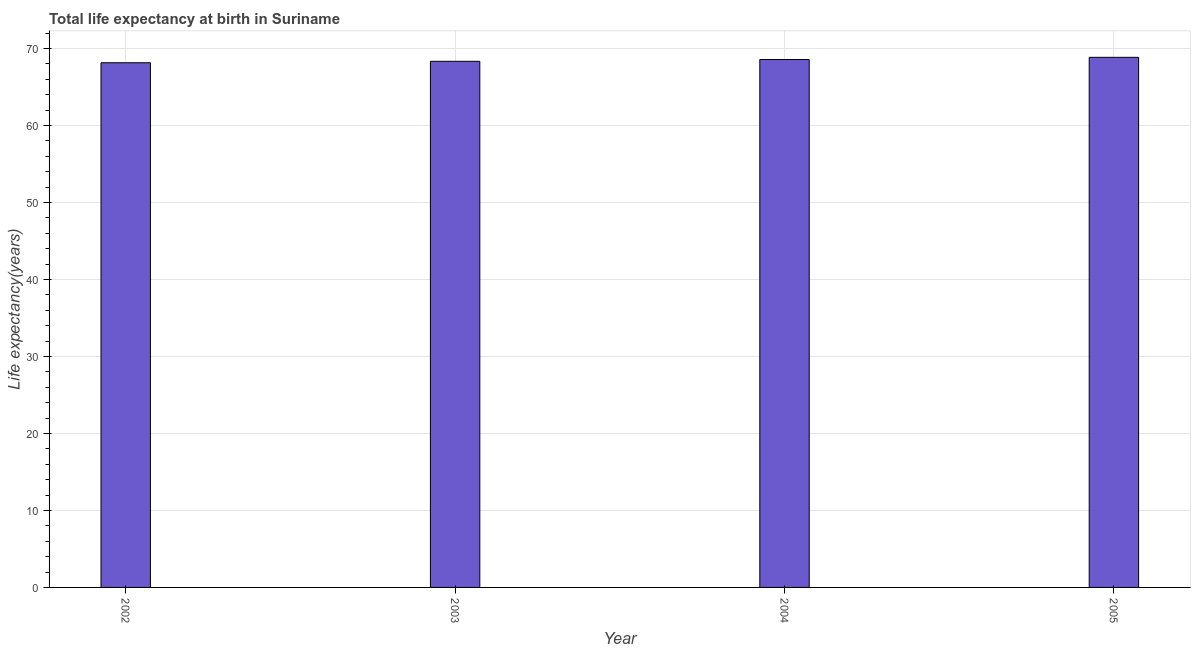Does the graph contain any zero values?
Your answer should be very brief. No. Does the graph contain grids?
Make the answer very short. Yes. What is the title of the graph?
Keep it short and to the point. Total life expectancy at birth in Suriname. What is the label or title of the Y-axis?
Offer a very short reply. Life expectancy(years). What is the life expectancy at birth in 2005?
Make the answer very short. 68.85. Across all years, what is the maximum life expectancy at birth?
Give a very brief answer. 68.85. Across all years, what is the minimum life expectancy at birth?
Your answer should be compact. 68.14. What is the sum of the life expectancy at birth?
Your response must be concise. 273.89. What is the difference between the life expectancy at birth in 2002 and 2004?
Provide a short and direct response. -0.42. What is the average life expectancy at birth per year?
Your answer should be compact. 68.47. What is the median life expectancy at birth?
Provide a succinct answer. 68.45. In how many years, is the life expectancy at birth greater than 2 years?
Offer a very short reply. 4. What is the ratio of the life expectancy at birth in 2002 to that in 2003?
Keep it short and to the point. 1. What is the difference between the highest and the second highest life expectancy at birth?
Offer a terse response. 0.28. Is the sum of the life expectancy at birth in 2004 and 2005 greater than the maximum life expectancy at birth across all years?
Keep it short and to the point. Yes. In how many years, is the life expectancy at birth greater than the average life expectancy at birth taken over all years?
Your answer should be compact. 2. How many bars are there?
Make the answer very short. 4. What is the Life expectancy(years) in 2002?
Your answer should be very brief. 68.14. What is the Life expectancy(years) in 2003?
Your answer should be compact. 68.33. What is the Life expectancy(years) in 2004?
Give a very brief answer. 68.57. What is the Life expectancy(years) of 2005?
Give a very brief answer. 68.85. What is the difference between the Life expectancy(years) in 2002 and 2003?
Give a very brief answer. -0.19. What is the difference between the Life expectancy(years) in 2002 and 2004?
Offer a terse response. -0.42. What is the difference between the Life expectancy(years) in 2002 and 2005?
Keep it short and to the point. -0.7. What is the difference between the Life expectancy(years) in 2003 and 2004?
Provide a short and direct response. -0.24. What is the difference between the Life expectancy(years) in 2003 and 2005?
Your answer should be compact. -0.52. What is the difference between the Life expectancy(years) in 2004 and 2005?
Offer a very short reply. -0.28. What is the ratio of the Life expectancy(years) in 2002 to that in 2003?
Your answer should be very brief. 1. What is the ratio of the Life expectancy(years) in 2002 to that in 2004?
Offer a very short reply. 0.99. What is the ratio of the Life expectancy(years) in 2002 to that in 2005?
Offer a terse response. 0.99. What is the ratio of the Life expectancy(years) in 2004 to that in 2005?
Make the answer very short. 1. 